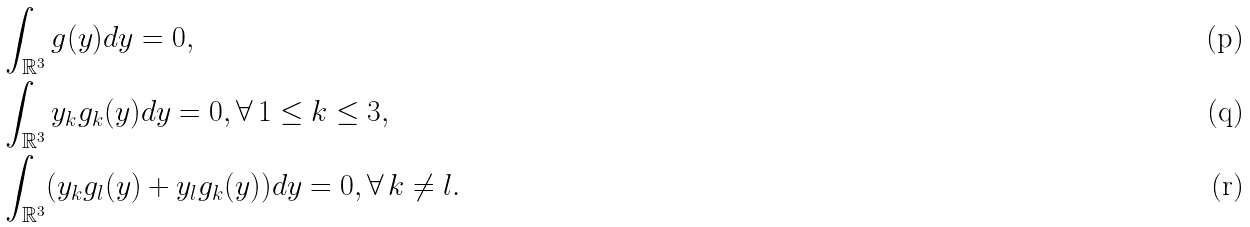Convert formula to latex. <formula><loc_0><loc_0><loc_500><loc_500>& \int _ { \mathbb { R } ^ { 3 } } g ( y ) d y = 0 , \\ & \int _ { \mathbb { R } ^ { 3 } } y _ { k } g _ { k } ( y ) d y = 0 , \forall \, 1 \leq k \leq 3 , \\ & \int _ { \mathbb { R } ^ { 3 } } ( y _ { k } g _ { l } ( y ) + y _ { l } g _ { k } ( y ) ) d y = 0 , \forall \, k \ne l .</formula> 